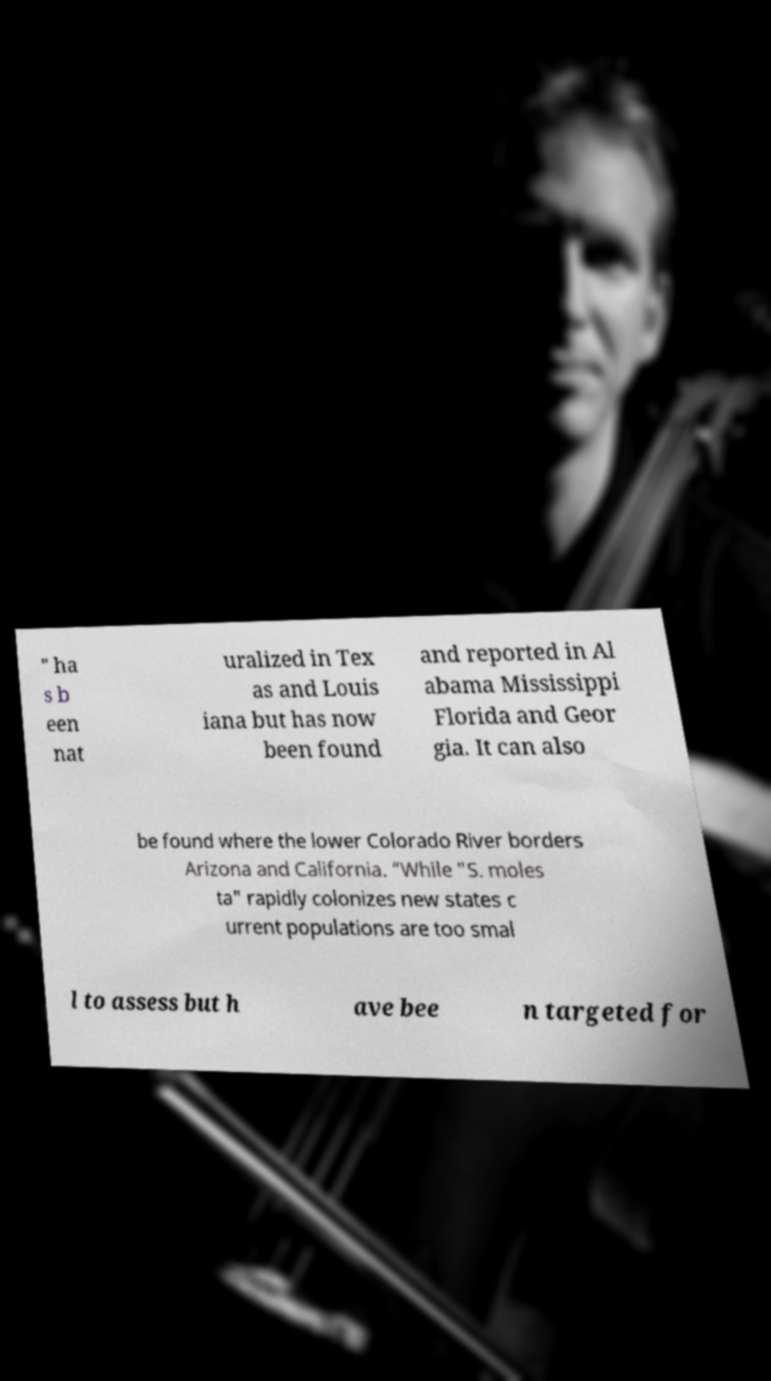Can you accurately transcribe the text from the provided image for me? " ha s b een nat uralized in Tex as and Louis iana but has now been found and reported in Al abama Mississippi Florida and Geor gia. It can also be found where the lower Colorado River borders Arizona and California. “While "S. moles ta" rapidly colonizes new states c urrent populations are too smal l to assess but h ave bee n targeted for 